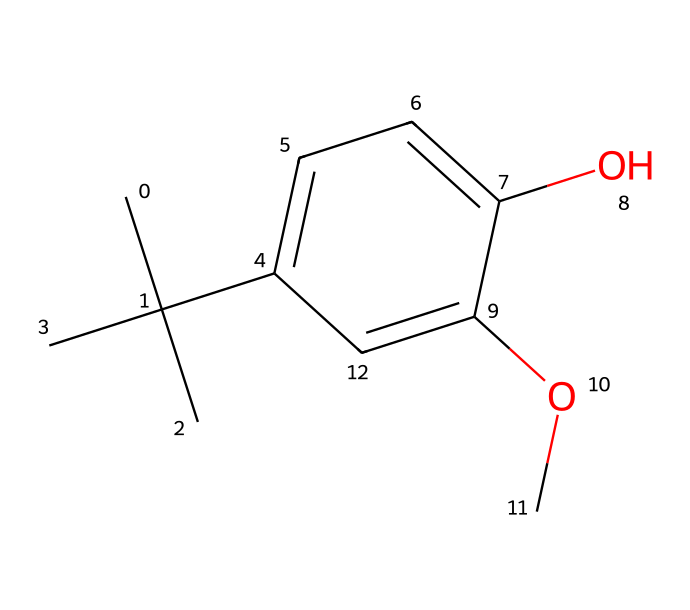What is the molecular formula of butylated hydroxyanisole (BHA)? To determine the molecular formula, count the number of each type of atom in the SMILES representation. For this molecule, there are 11 carbon (C) atoms, 16 hydrogen (H) atoms, and 3 oxygen (O) atoms. Therefore, the molecular formula is C11H16O3.
Answer: C11H16O3 How many aromatic rings are present in the chemical structure of BHA? The presence of an aromatic ring can be identified by the "c" notation in the SMILES string. The structure shows a single six-membered ring with alternating double bonds, indicating one aromatic ring.
Answer: 1 What functional groups can be identified in the structure of BHA? Looking closely at the chemical structure, BHA has a methoxy group (–OCH3) and a hydroxyl group (–OH) attached to the aromatic ring, both of which are functional groups.
Answer: methoxy and hydroxyl What type of chemical reaction might butylated hydroxyanisole (BHA) typically undergo? BHA is an antioxidant, so it primarily participates in redox reactions where it donates electrons to react with free radicals, thus preventing oxidation.
Answer: redox reactions Which part of BHA provides its preservative properties? The hydroxyl group (–OH) in BHA is crucial for its antioxidant activity. It donates hydrogen atoms to the free radicals, thus stabilizing them and preventing further reactions that could spoil products.
Answer: hydroxyl group What allows BHA to be soluble in oils? The presence of both hydrophobic (the long carbon chain) and hydrophilic (the hydroxyl and methoxy groups) parts allows BHA to dissolve well in oils, making it suitable as a preservative in oil-based products.
Answer: hydrophobic and hydrophilic parts How does the structure of BHA affect its stability as a preservative? The bulky tert-butyl group and the presence of the hydroxyl group contribute to BHA's stability. The bulky structure hinders oxidative degradation while the hydroxyl group helps donate electrons in redox reactions.
Answer: bulky tert-butyl group and hydroxyl group 